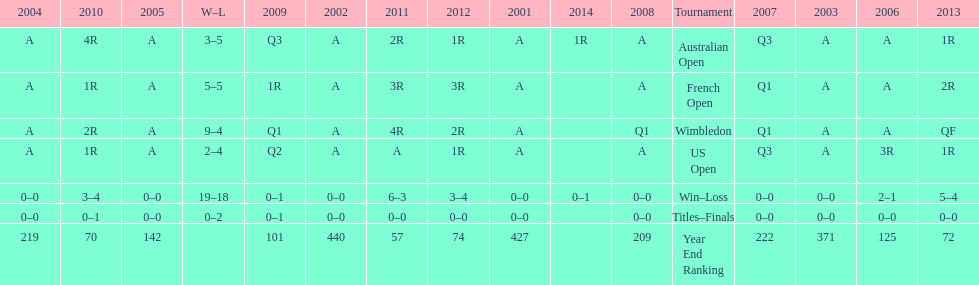In what years was a ranking of below 200 reached? 2005, 2006, 2009, 2010, 2011, 2012, 2013. 